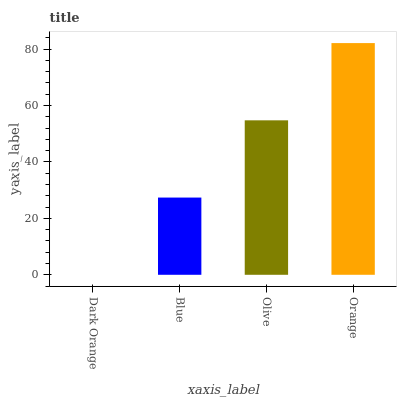Is Dark Orange the minimum?
Answer yes or no. Yes. Is Orange the maximum?
Answer yes or no. Yes. Is Blue the minimum?
Answer yes or no. No. Is Blue the maximum?
Answer yes or no. No. Is Blue greater than Dark Orange?
Answer yes or no. Yes. Is Dark Orange less than Blue?
Answer yes or no. Yes. Is Dark Orange greater than Blue?
Answer yes or no. No. Is Blue less than Dark Orange?
Answer yes or no. No. Is Olive the high median?
Answer yes or no. Yes. Is Blue the low median?
Answer yes or no. Yes. Is Blue the high median?
Answer yes or no. No. Is Orange the low median?
Answer yes or no. No. 